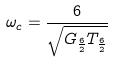<formula> <loc_0><loc_0><loc_500><loc_500>\omega _ { c } = \frac { 6 } { \sqrt { G _ { \frac { 6 } { 2 } } T _ { \frac { 6 } { 2 } } } }</formula> 